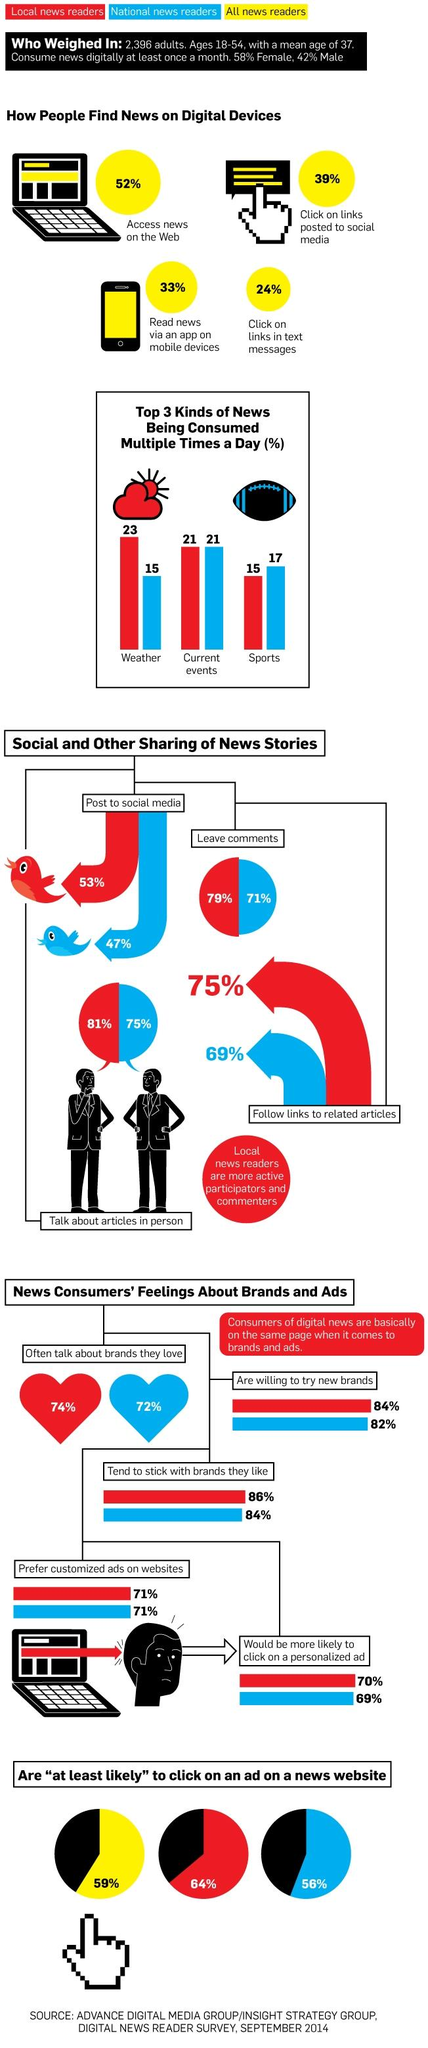Indicate a few pertinent items in this graphic. According to a survey, 75% of national news readers aged 18-54 years report discussing articles with others in person. According to a survey of local news readers aged 18-54, 84% are willing to try new brands. According to a survey, 47% of national news readers aged 18-54 years post news stories to social media. According to the survey, 33% of all news readers aged 18-54 years read news through an app on mobile devices. According to data, 42% of men aged 18-54 years consume news digitally at least once a month. 